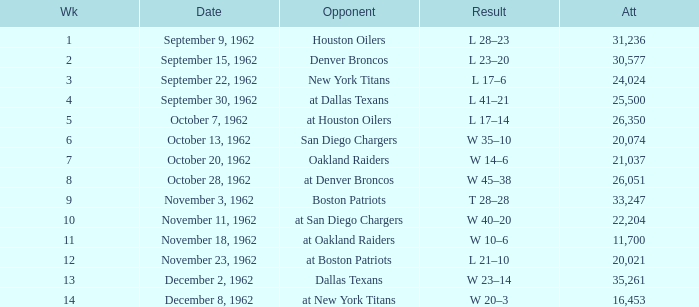What week was the attendance smaller than 22,204 on December 8, 1962? 14.0. 